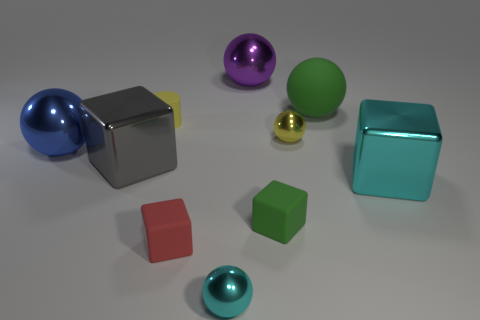Subtract all big cyan blocks. How many blocks are left? 3 Subtract all blue spheres. How many spheres are left? 4 Subtract all cylinders. How many objects are left? 9 Add 2 tiny yellow spheres. How many tiny yellow spheres are left? 3 Add 2 big rubber cylinders. How many big rubber cylinders exist? 2 Subtract 0 red balls. How many objects are left? 10 Subtract all cyan spheres. Subtract all green cylinders. How many spheres are left? 4 Subtract all large green rubber spheres. Subtract all large blue things. How many objects are left? 8 